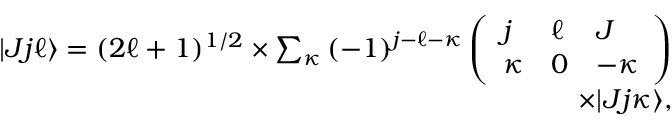<formula> <loc_0><loc_0><loc_500><loc_500>\begin{array} { r } { | J j \ell \rangle = ( 2 \ell + 1 ) ^ { 1 / 2 } \times \sum _ { \kappa ( - 1 ) ^ { j - \ell - \kappa } \left ( \begin{array} { l l l } { j } & { \ell } & { J } \\ { \kappa } & { 0 } & { - \kappa } \end{array} \right ) } \\ { \times | J j \kappa \rangle , } \end{array}</formula> 